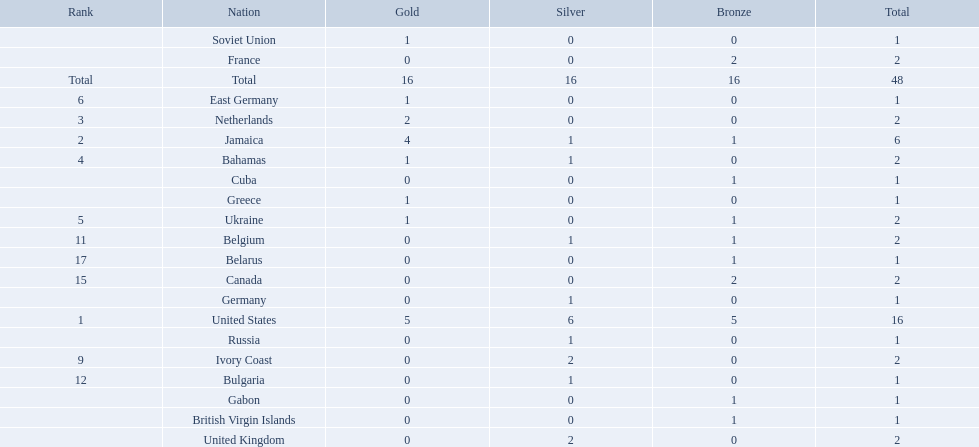Which countries competed in the 60 meters competition? United States, Jamaica, Netherlands, Bahamas, Ukraine, East Germany, Greece, Soviet Union, Ivory Coast, United Kingdom, Belgium, Bulgaria, Russia, Germany, Canada, France, Belarus, Cuba, Gabon, British Virgin Islands. And how many gold medals did they win? 5, 4, 2, 1, 1, 1, 1, 1, 0, 0, 0, 0, 0, 0, 0, 0, 0, 0, 0, 0. Of those countries, which won the second highest number gold medals? Jamaica. 